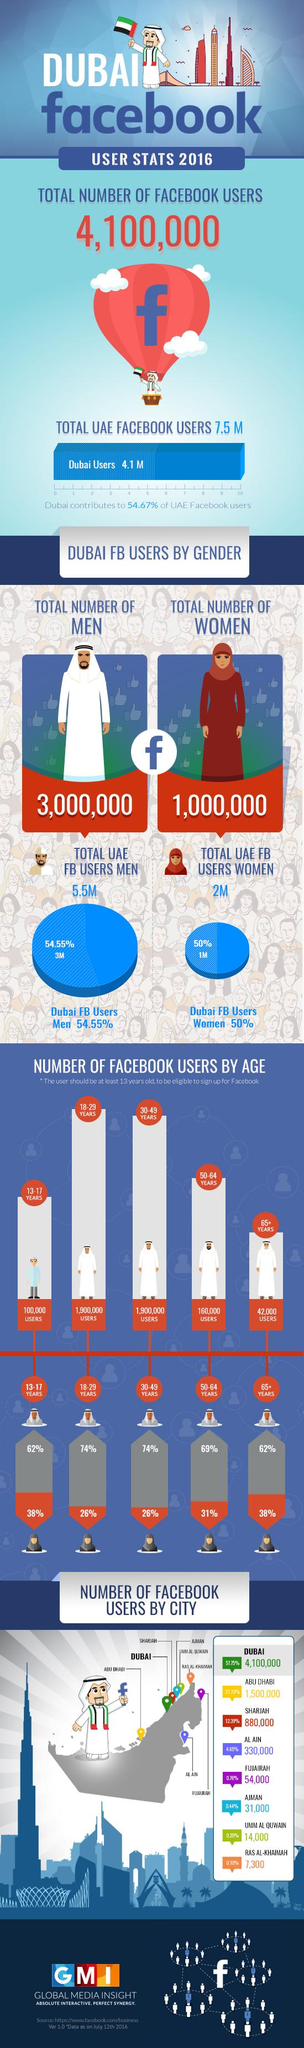Point out several critical features in this image. Six cities in the United Arab Emirates have a total number of Facebook users that is less than one million. According to the data, the 18-29 age group is the most active on Facebook. Ras Al-Khaimah is the city in the UAE that contributes the least number of Facebook users. According to recent data, there are approximately 2.9 million Facebook users under the age of 30. According to the data, 31% of Facebook users in the age group of 50-64 are women. 